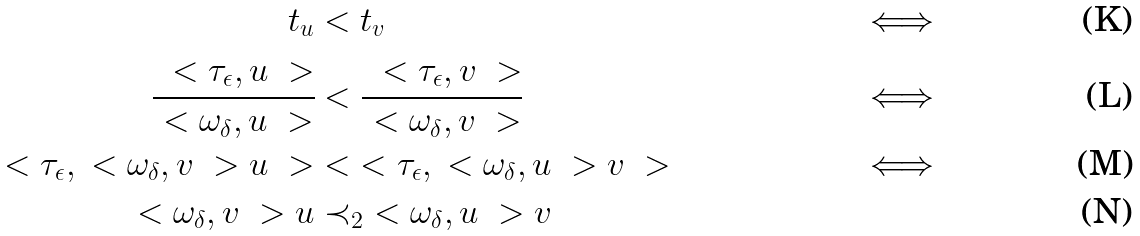<formula> <loc_0><loc_0><loc_500><loc_500>t _ { u } & < t _ { v } & \iff \\ \cfrac { \ < \tau _ { \epsilon } , u \ > } { \ < \omega _ { \delta } , u \ > } & < \cfrac { \ < \tau _ { \epsilon } , v \ > } { \ < \omega _ { \delta } , v \ > } & \iff \\ \ < \tau _ { \epsilon } , \ < \omega _ { \delta } , v \ > u \ > & < \ < \tau _ { \epsilon } , \ < \omega _ { \delta } , u \ > v \ > & \iff \\ \ < \omega _ { \delta } , v \ > u & \prec _ { 2 } \ < \omega _ { \delta } , u \ > v</formula> 